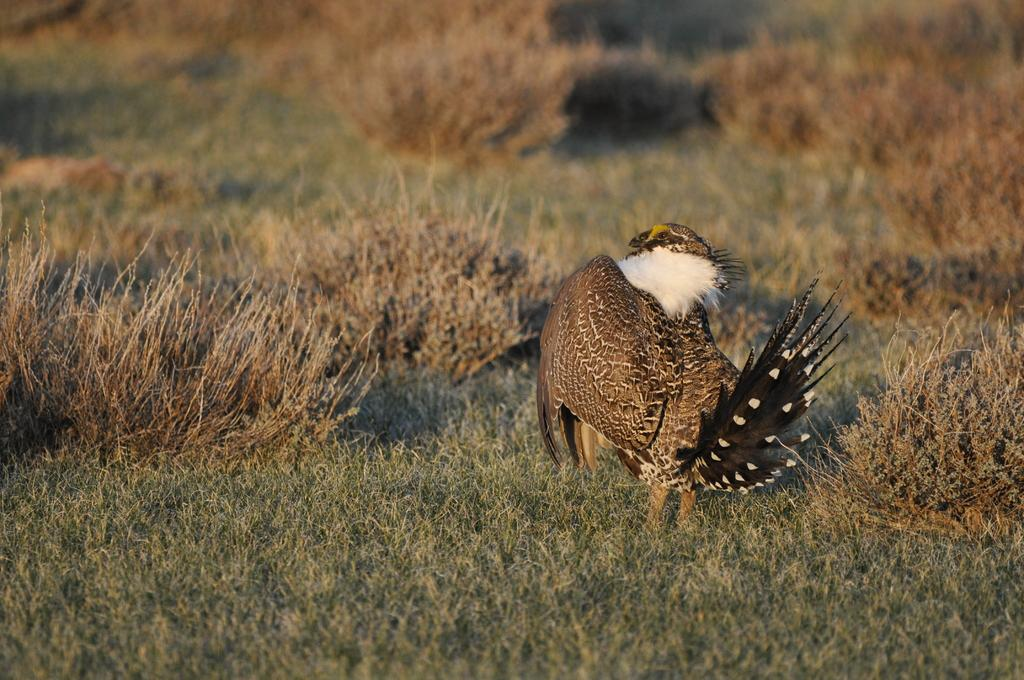What type of animal is in the picture? There is a bird in the picture. What colors can be seen on the bird? The bird has brown and black colors. What type of vegetation is at the bottom of the image? There are plants at the bottom of the image. What type of ground cover is visible in the image? There is grass visible in the image. Where can the friends be seen hanging out in the image? There is no reference to friends in the image, so it is not possible to answer that question. 